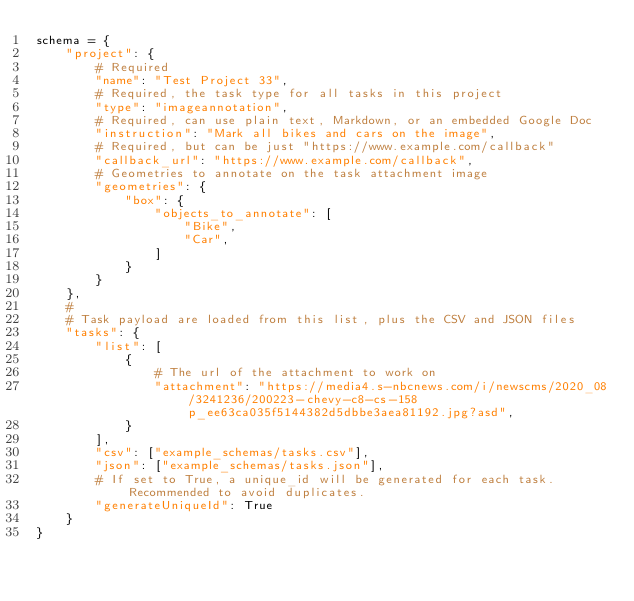<code> <loc_0><loc_0><loc_500><loc_500><_Python_>schema = {
    "project": {
        # Required
        "name": "Test Project 33",
        # Required, the task type for all tasks in this project
        "type": "imageannotation",
        # Required, can use plain text, Markdown, or an embedded Google Doc
        "instruction": "Mark all bikes and cars on the image",
        # Required, but can be just "https://www.example.com/callback"
        "callback_url": "https://www.example.com/callback",
        # Geometries to annotate on the task attachment image
        "geometries": {
            "box": {
                "objects_to_annotate": [
                    "Bike",
                    "Car",
                ]
            }
        }
    },
    #
    # Task payload are loaded from this list, plus the CSV and JSON files
    "tasks": {
        "list": [
            {
                # The url of the attachment to work on
                "attachment": "https://media4.s-nbcnews.com/i/newscms/2020_08/3241236/200223-chevy-c8-cs-158p_ee63ca035f5144382d5dbbe3aea81192.jpg?asd",
            }
        ],
        "csv": ["example_schemas/tasks.csv"],
        "json": ["example_schemas/tasks.json"],
        # If set to True, a unique_id will be generated for each task. Recommended to avoid duplicates.
        "generateUniqueId": True
    }
}
</code> 